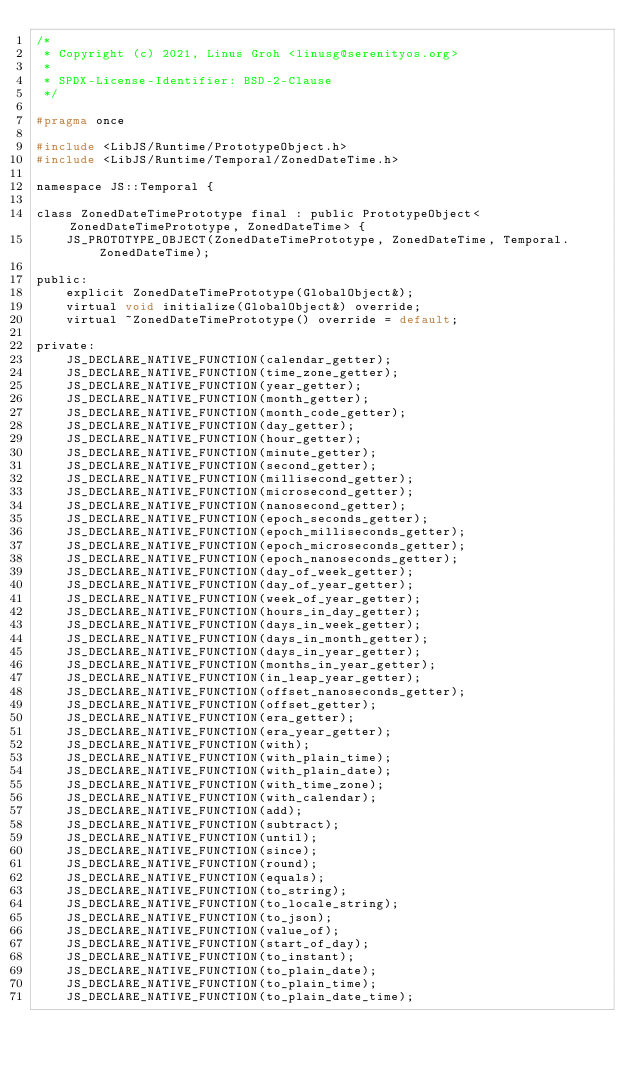Convert code to text. <code><loc_0><loc_0><loc_500><loc_500><_C_>/*
 * Copyright (c) 2021, Linus Groh <linusg@serenityos.org>
 *
 * SPDX-License-Identifier: BSD-2-Clause
 */

#pragma once

#include <LibJS/Runtime/PrototypeObject.h>
#include <LibJS/Runtime/Temporal/ZonedDateTime.h>

namespace JS::Temporal {

class ZonedDateTimePrototype final : public PrototypeObject<ZonedDateTimePrototype, ZonedDateTime> {
    JS_PROTOTYPE_OBJECT(ZonedDateTimePrototype, ZonedDateTime, Temporal.ZonedDateTime);

public:
    explicit ZonedDateTimePrototype(GlobalObject&);
    virtual void initialize(GlobalObject&) override;
    virtual ~ZonedDateTimePrototype() override = default;

private:
    JS_DECLARE_NATIVE_FUNCTION(calendar_getter);
    JS_DECLARE_NATIVE_FUNCTION(time_zone_getter);
    JS_DECLARE_NATIVE_FUNCTION(year_getter);
    JS_DECLARE_NATIVE_FUNCTION(month_getter);
    JS_DECLARE_NATIVE_FUNCTION(month_code_getter);
    JS_DECLARE_NATIVE_FUNCTION(day_getter);
    JS_DECLARE_NATIVE_FUNCTION(hour_getter);
    JS_DECLARE_NATIVE_FUNCTION(minute_getter);
    JS_DECLARE_NATIVE_FUNCTION(second_getter);
    JS_DECLARE_NATIVE_FUNCTION(millisecond_getter);
    JS_DECLARE_NATIVE_FUNCTION(microsecond_getter);
    JS_DECLARE_NATIVE_FUNCTION(nanosecond_getter);
    JS_DECLARE_NATIVE_FUNCTION(epoch_seconds_getter);
    JS_DECLARE_NATIVE_FUNCTION(epoch_milliseconds_getter);
    JS_DECLARE_NATIVE_FUNCTION(epoch_microseconds_getter);
    JS_DECLARE_NATIVE_FUNCTION(epoch_nanoseconds_getter);
    JS_DECLARE_NATIVE_FUNCTION(day_of_week_getter);
    JS_DECLARE_NATIVE_FUNCTION(day_of_year_getter);
    JS_DECLARE_NATIVE_FUNCTION(week_of_year_getter);
    JS_DECLARE_NATIVE_FUNCTION(hours_in_day_getter);
    JS_DECLARE_NATIVE_FUNCTION(days_in_week_getter);
    JS_DECLARE_NATIVE_FUNCTION(days_in_month_getter);
    JS_DECLARE_NATIVE_FUNCTION(days_in_year_getter);
    JS_DECLARE_NATIVE_FUNCTION(months_in_year_getter);
    JS_DECLARE_NATIVE_FUNCTION(in_leap_year_getter);
    JS_DECLARE_NATIVE_FUNCTION(offset_nanoseconds_getter);
    JS_DECLARE_NATIVE_FUNCTION(offset_getter);
    JS_DECLARE_NATIVE_FUNCTION(era_getter);
    JS_DECLARE_NATIVE_FUNCTION(era_year_getter);
    JS_DECLARE_NATIVE_FUNCTION(with);
    JS_DECLARE_NATIVE_FUNCTION(with_plain_time);
    JS_DECLARE_NATIVE_FUNCTION(with_plain_date);
    JS_DECLARE_NATIVE_FUNCTION(with_time_zone);
    JS_DECLARE_NATIVE_FUNCTION(with_calendar);
    JS_DECLARE_NATIVE_FUNCTION(add);
    JS_DECLARE_NATIVE_FUNCTION(subtract);
    JS_DECLARE_NATIVE_FUNCTION(until);
    JS_DECLARE_NATIVE_FUNCTION(since);
    JS_DECLARE_NATIVE_FUNCTION(round);
    JS_DECLARE_NATIVE_FUNCTION(equals);
    JS_DECLARE_NATIVE_FUNCTION(to_string);
    JS_DECLARE_NATIVE_FUNCTION(to_locale_string);
    JS_DECLARE_NATIVE_FUNCTION(to_json);
    JS_DECLARE_NATIVE_FUNCTION(value_of);
    JS_DECLARE_NATIVE_FUNCTION(start_of_day);
    JS_DECLARE_NATIVE_FUNCTION(to_instant);
    JS_DECLARE_NATIVE_FUNCTION(to_plain_date);
    JS_DECLARE_NATIVE_FUNCTION(to_plain_time);
    JS_DECLARE_NATIVE_FUNCTION(to_plain_date_time);</code> 